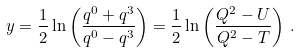Convert formula to latex. <formula><loc_0><loc_0><loc_500><loc_500>y = \frac { 1 } { 2 } \ln \left ( \frac { q ^ { 0 } + q ^ { 3 } } { q ^ { 0 } - q ^ { 3 } } \right ) = \frac { 1 } { 2 } \ln \left ( \frac { Q ^ { 2 } - U } { Q ^ { 2 } - T } \right ) \, .</formula> 